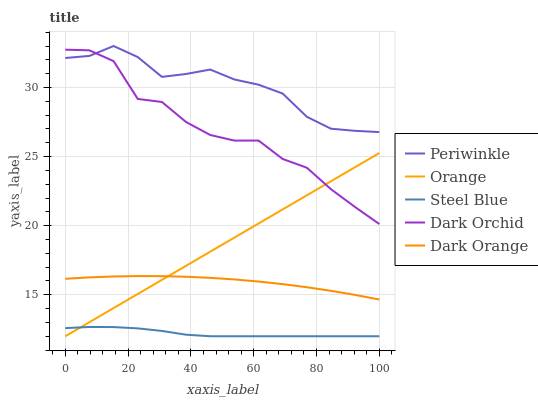Does Dark Orange have the minimum area under the curve?
Answer yes or no. No. Does Dark Orange have the maximum area under the curve?
Answer yes or no. No. Is Dark Orange the smoothest?
Answer yes or no. No. Is Dark Orange the roughest?
Answer yes or no. No. Does Dark Orange have the lowest value?
Answer yes or no. No. Does Dark Orange have the highest value?
Answer yes or no. No. Is Orange less than Periwinkle?
Answer yes or no. Yes. Is Dark Orchid greater than Dark Orange?
Answer yes or no. Yes. Does Orange intersect Periwinkle?
Answer yes or no. No. 